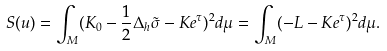Convert formula to latex. <formula><loc_0><loc_0><loc_500><loc_500>S ( u ) = \int _ { M } ( K _ { 0 } - \frac { 1 } { 2 } \Delta _ { h } \tilde { \sigma } - K e ^ { \tau } ) ^ { 2 } d \mu = \int _ { M } ( - L - K e ^ { \tau } ) ^ { 2 } d \mu .</formula> 